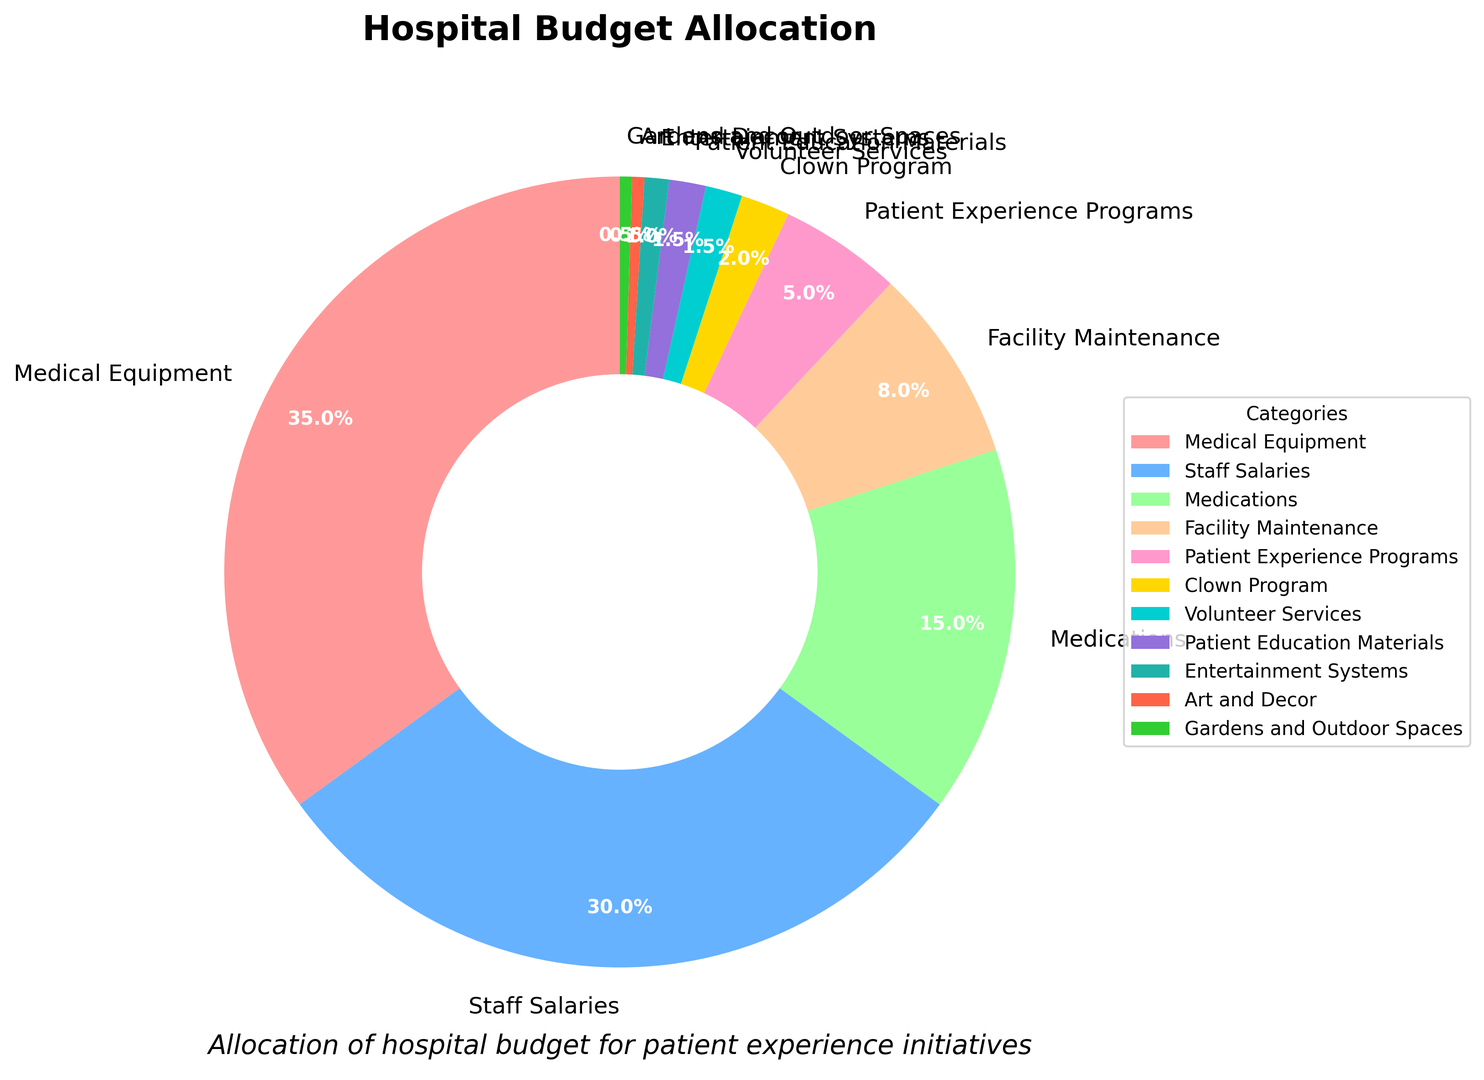what's the largest category of the hospital budget allocation? By inspecting the pie chart, the largest slice corresponds to the category labeled "Medical Equipment" with 35% of the total budget allocation.
Answer: Medical Equipment Which two categories have the smallest budget allocations? Observing the pie chart, the smallest slices are for "Gardens and Outdoor Spaces" and "Art and Decor," each with 0.5%.
Answer: Gardens and Outdoor Spaces, Art and Decor How do the budget allocations for Patient Experience Programs and Clown Program compare? The pie chart shows that Patient Experience Programs have an allocation of 5%, whereas the Clown Program has a 2% allocation. Patient Experience Programs receive a higher percentage of the budget.
Answer: Patient Experience Programs receive more What is the combined budget allocation for Staff Salaries and Medications? Adding the percentages for Staff Salaries (30%) and Medications (15%) results in a combined budget allocation of 45%.
Answer: 45% How much larger is the budget allocation for Facility Maintenance than for Entertainment Systems? The pie chart indicates Facility Maintenance has an 8% allocation, whereas Entertainment Systems have a 1% allocation. The difference is 8% - 1% = 7%.
Answer: 7% What is the total percentage allocated to arts-related categories, including Art and Decor and Gardens and Outdoor Spaces? Summing up the allocations for Art and Decor (0.5%) and Gardens and Outdoor Spaces (0.5%) results in 0.5% + 0.5% = 1%.
Answer: 1% Are there any categories with identical budget allocations? The pie chart shows that both Volunteer Services and Patient Education Materials are allocated 1.5% of the budget each.
Answer: Yes, Volunteer Services and Patient Education Materials How does the allocation for Medical Equipment compare to the combined budget for all categories related to patient experience (Patient Experience Programs, Clown Program, Volunteer Services, Patient Education Materials, Entertainment Systems, Art and Decor, Gardens and Outdoor Spaces)? The allocations for patient experience-related categories are 5% (Patient Experience Programs) + 2% (Clown Program) + 1.5% (Volunteer Services) + 1.5% (Patient Education Materials) + 1% (Entertainment Systems) + 0.5% (Art and Decor) + 0.5% (Gardens and Outdoor Spaces) = 12%. Medical Equipment has a 35% allocation, which is larger than the combined total of 12% for patient experience-related categories.
Answer: Medical Equipment is larger 